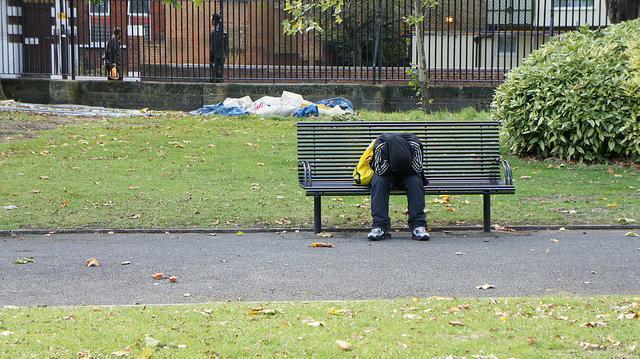Where were the first free public benches invented?
Make your selection and explain in format: 'Answer: answer
Rationale: rationale.'
Options: Spain, morocco, america, france. Answer: france.
Rationale: The first public benches were invented in france. Where is the head of this person?
From the following set of four choices, select the accurate answer to respond to the question.
Options: Behind them, above shoulders, above knees, no where. Above knees. 